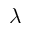Convert formula to latex. <formula><loc_0><loc_0><loc_500><loc_500>\lambda</formula> 